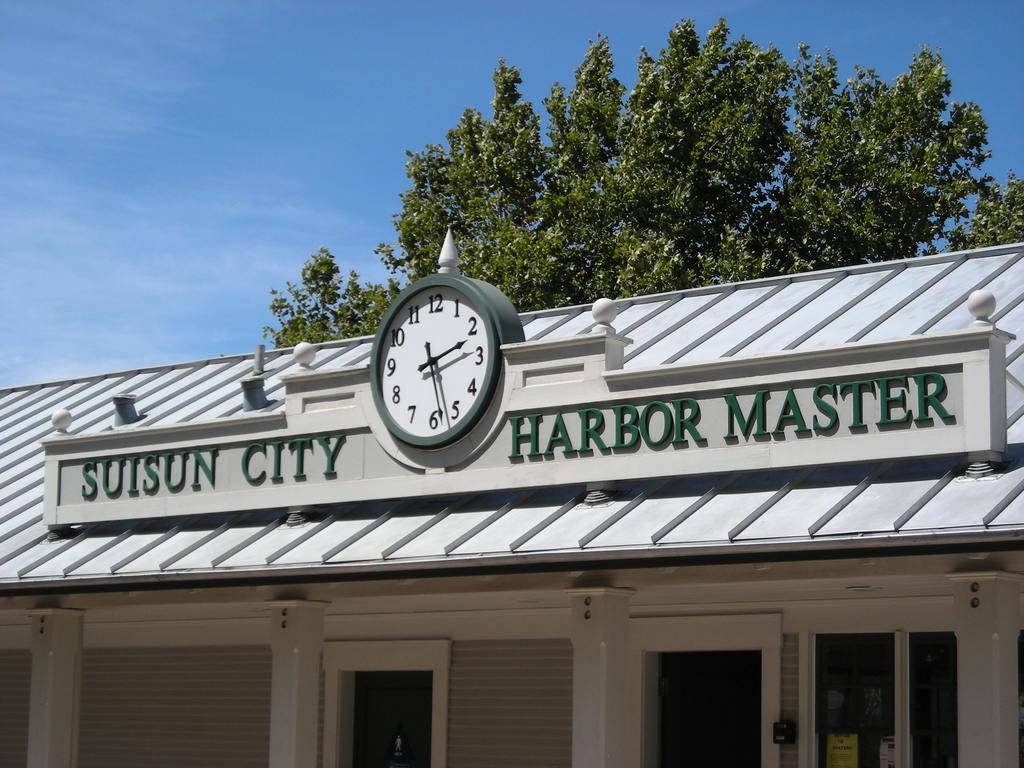Which city does this take place in?
Provide a succinct answer. Suisun city. 